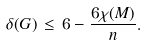Convert formula to latex. <formula><loc_0><loc_0><loc_500><loc_500>\delta ( G ) \, \leq \, 6 - \frac { 6 \chi ( M ) } { n } .</formula> 